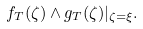Convert formula to latex. <formula><loc_0><loc_0><loc_500><loc_500>f _ { T } ( \zeta ) \wedge g _ { T } ( \zeta ) | _ { \zeta = \xi } .</formula> 